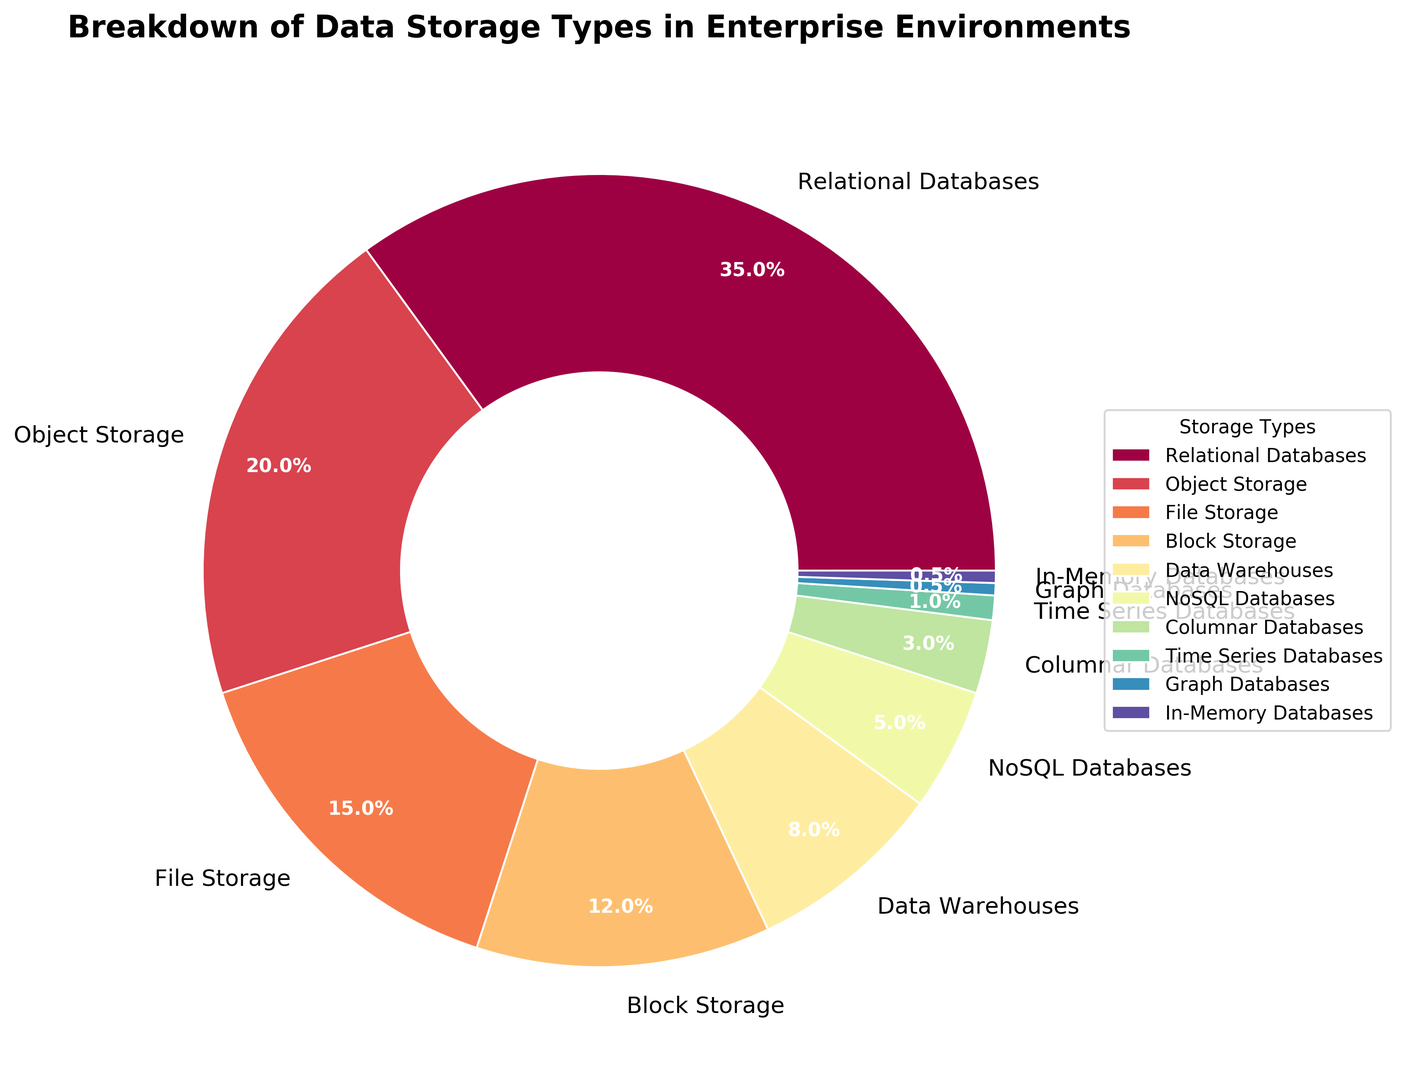What percentage of data storage types make up under 10% each? Add the percentages for Data Warehouses (8%), NoSQL Databases (5%), Columnar Databases (3%), Time Series Databases (1%), Graph Databases (0.5%), and In-Memory Databases (0.5%): 8 + 5 + 3 + 1 + 0.5 + 0.5 = 18%.
Answer: 18% Which storage type is the most widely used in enterprise environments? The storage type with the largest percentage in the pie chart is Relational Databases at 35%.
Answer: Relational Databases How do Relational Databases and Object Storage compare in percentage? Relational Databases make up 35% while Object Storage accounts for 20%. To compare, 35% is greater than 20%.
Answer: 35% > 20% What is the combined percentage of File Storage and Block Storage? Add the percentages of File Storage (15%) and Block Storage (12%): 15 + 12 = 27%.
Answer: 27% Which storage types have the same percentage? Both Graph Databases and In-Memory Databases each make up 0.5%.
Answer: Graph Databases and In-Memory Databases Is the percentage of NoSQL Databases higher than that of Data Warehouses? NoSQL Databases have a percentage of 5% while Data Warehouses have a percentage of 8%. Therefore, NoSQL Databases is less than Data Warehouses.
Answer: No What is the total percentage of storage types that use traditional relational models (Relational Databases and Columnar Databases)? Add the percentages for Relational Databases (35%) and Columnar Databases (3%): 35 + 3 = 38%.
Answer: 38% Which storage type has the smallest representation in the pie chart? The storage types with the smallest representation in the pie chart are Graph Databases and In-Memory Databases, each with 0.5%.
Answer: Graph Databases and In-Memory Databases 